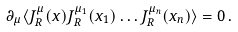Convert formula to latex. <formula><loc_0><loc_0><loc_500><loc_500>\partial _ { \mu } \langle J _ { R } ^ { \mu } ( x ) J _ { R } ^ { \mu _ { 1 } } ( x _ { 1 } ) \dots J _ { R } ^ { \mu _ { n } } ( x _ { n } ) \rangle = 0 \, .</formula> 